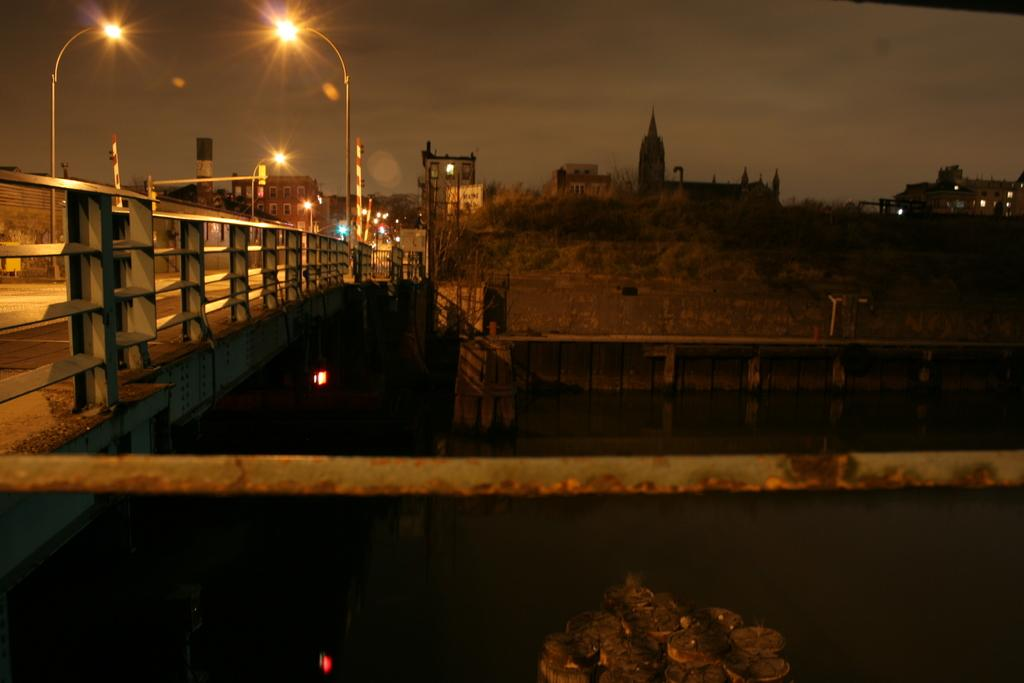What is the main structure in the image? There is a bridge in the image. What is the bridge positioned over? The bridge is across a river. What can be seen on the bridge? There are many street lights on the bridge. What is visible in the background of the image? There are buildings in the background of the image. How many sticks are being used to hold the parcel in the image? There is no parcel or sticks present in the image. What type of scene is depicted in the image? The image depicts a bridge across a river with street lights and buildings in the background, but it does not represent a specific scene or event. 